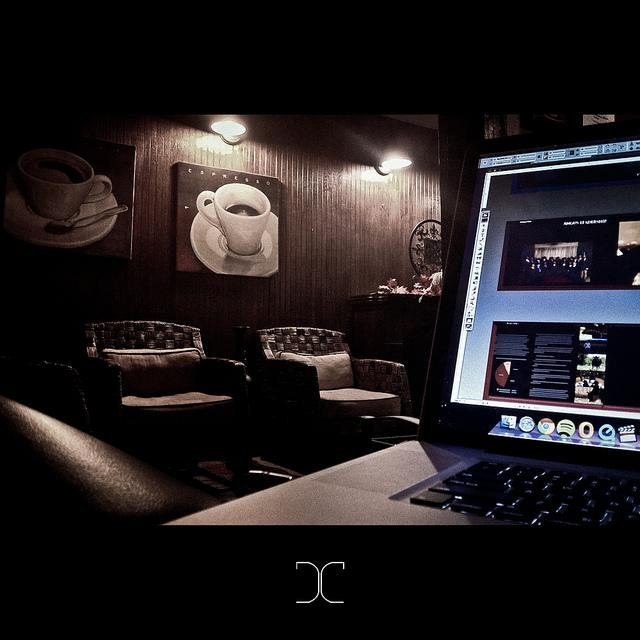What company is the main competitor to the laptop's operating system?

Choices:
A) microsoft
B) apple
C) samsung
D) android microsoft 